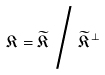Convert formula to latex. <formula><loc_0><loc_0><loc_500><loc_500>\mathfrak { K } = \widetilde { \mathfrak { K } } \, \Big / \, \widetilde { \mathfrak { K } } ^ { \bot }</formula> 